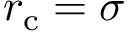Convert formula to latex. <formula><loc_0><loc_0><loc_500><loc_500>r _ { c } = \sigma</formula> 